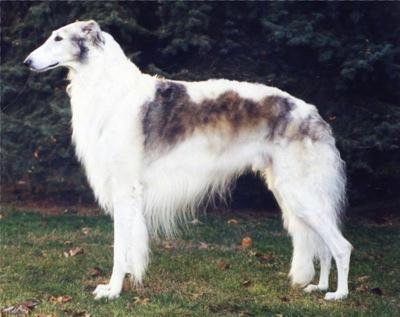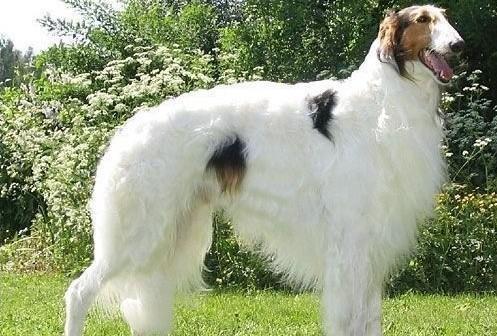The first image is the image on the left, the second image is the image on the right. Given the left and right images, does the statement "Each image contains exactly one long-haired hound standing outdoors on all fours." hold true? Answer yes or no. Yes. The first image is the image on the left, the second image is the image on the right. For the images displayed, is the sentence "The dog in the left image is facing towards the left." factually correct? Answer yes or no. Yes. 